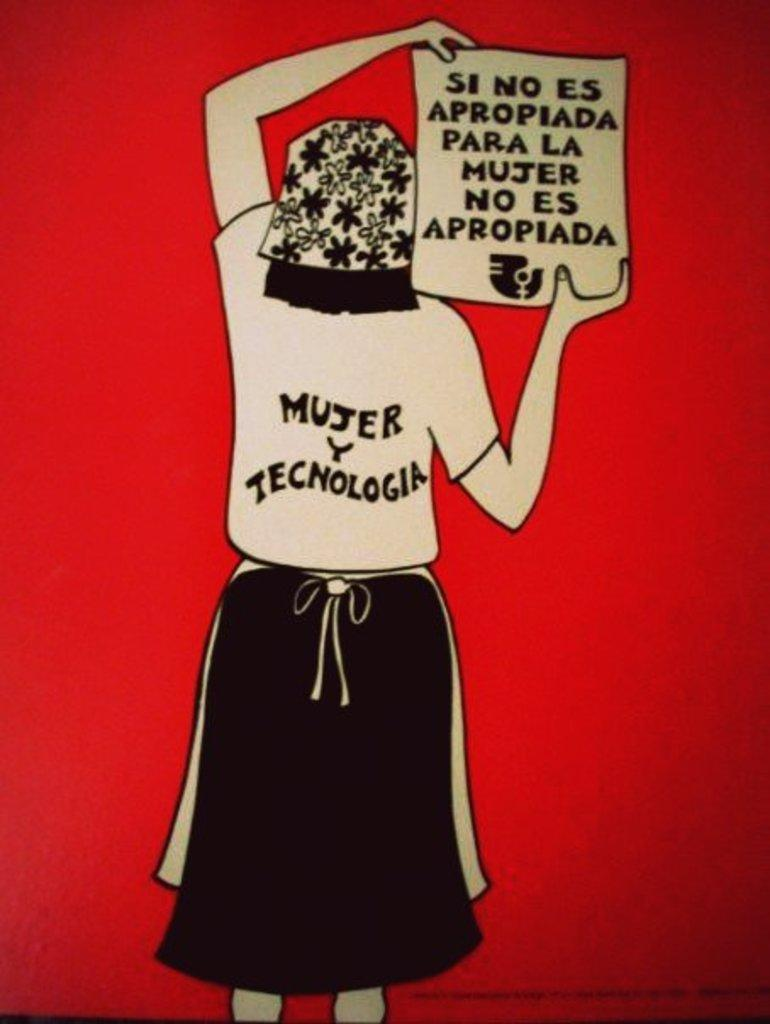What is depicted in the image? There is a painting of a person in the image. What is the person in the painting holding? The person in the painting is holding a sheet of paper. What color is the background of the painting? The background of the painting is red. What type of harmony is being played by the person in the painting? There is no indication of music or harmony in the painting; the person is simply holding a sheet of paper. 